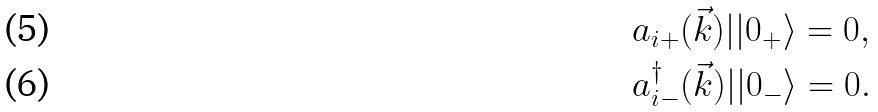Convert formula to latex. <formula><loc_0><loc_0><loc_500><loc_500>& a _ { i + } ( \vec { k } ) | | 0 _ { + } \rangle = 0 , \\ & a _ { i - } ^ { \dagger } ( \vec { k } ) | | 0 _ { - } \rangle = 0 .</formula> 